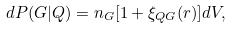Convert formula to latex. <formula><loc_0><loc_0><loc_500><loc_500>d P ( G | Q ) = n _ { G } [ 1 + \xi _ { Q G } ( r ) ] d V ,</formula> 